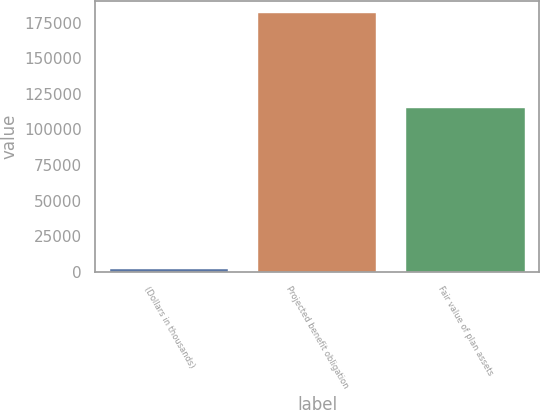<chart> <loc_0><loc_0><loc_500><loc_500><bar_chart><fcel>(Dollars in thousands)<fcel>Projected benefit obligation<fcel>Fair value of plan assets<nl><fcel>2012<fcel>181617<fcel>114807<nl></chart> 